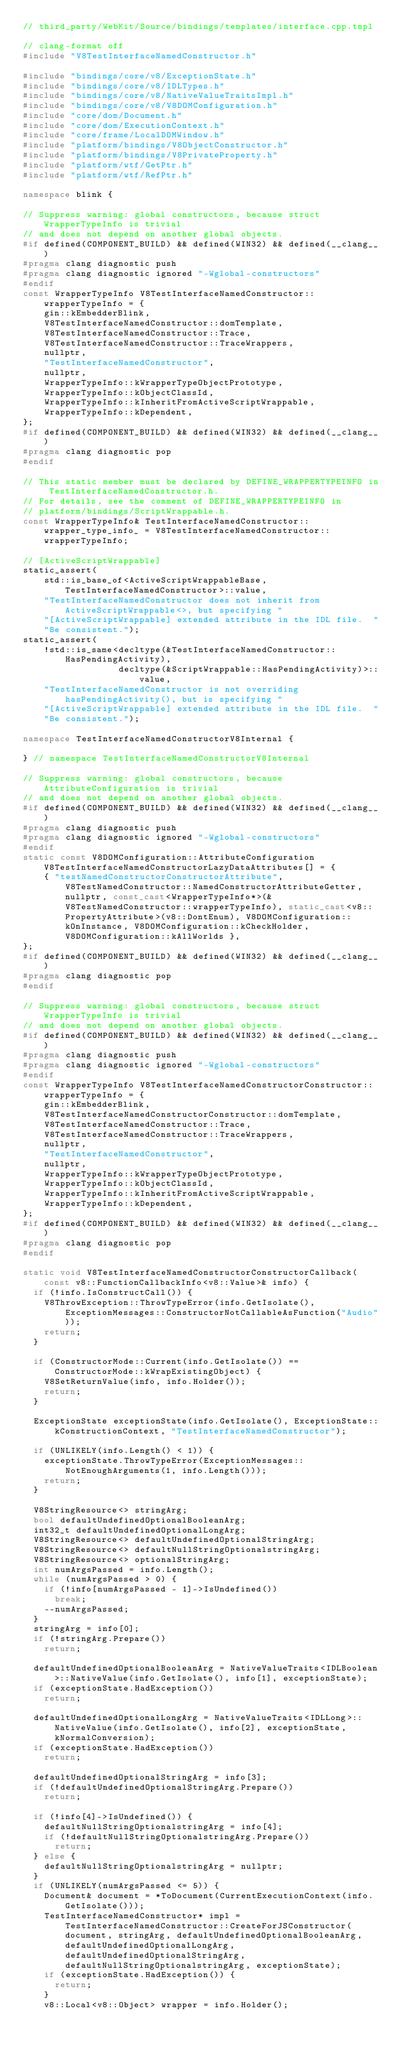Convert code to text. <code><loc_0><loc_0><loc_500><loc_500><_C++_>// third_party/WebKit/Source/bindings/templates/interface.cpp.tmpl

// clang-format off
#include "V8TestInterfaceNamedConstructor.h"

#include "bindings/core/v8/ExceptionState.h"
#include "bindings/core/v8/IDLTypes.h"
#include "bindings/core/v8/NativeValueTraitsImpl.h"
#include "bindings/core/v8/V8DOMConfiguration.h"
#include "core/dom/Document.h"
#include "core/dom/ExecutionContext.h"
#include "core/frame/LocalDOMWindow.h"
#include "platform/bindings/V8ObjectConstructor.h"
#include "platform/bindings/V8PrivateProperty.h"
#include "platform/wtf/GetPtr.h"
#include "platform/wtf/RefPtr.h"

namespace blink {

// Suppress warning: global constructors, because struct WrapperTypeInfo is trivial
// and does not depend on another global objects.
#if defined(COMPONENT_BUILD) && defined(WIN32) && defined(__clang__)
#pragma clang diagnostic push
#pragma clang diagnostic ignored "-Wglobal-constructors"
#endif
const WrapperTypeInfo V8TestInterfaceNamedConstructor::wrapperTypeInfo = {
    gin::kEmbedderBlink,
    V8TestInterfaceNamedConstructor::domTemplate,
    V8TestInterfaceNamedConstructor::Trace,
    V8TestInterfaceNamedConstructor::TraceWrappers,
    nullptr,
    "TestInterfaceNamedConstructor",
    nullptr,
    WrapperTypeInfo::kWrapperTypeObjectPrototype,
    WrapperTypeInfo::kObjectClassId,
    WrapperTypeInfo::kInheritFromActiveScriptWrappable,
    WrapperTypeInfo::kDependent,
};
#if defined(COMPONENT_BUILD) && defined(WIN32) && defined(__clang__)
#pragma clang diagnostic pop
#endif

// This static member must be declared by DEFINE_WRAPPERTYPEINFO in TestInterfaceNamedConstructor.h.
// For details, see the comment of DEFINE_WRAPPERTYPEINFO in
// platform/bindings/ScriptWrappable.h.
const WrapperTypeInfo& TestInterfaceNamedConstructor::wrapper_type_info_ = V8TestInterfaceNamedConstructor::wrapperTypeInfo;

// [ActiveScriptWrappable]
static_assert(
    std::is_base_of<ActiveScriptWrappableBase, TestInterfaceNamedConstructor>::value,
    "TestInterfaceNamedConstructor does not inherit from ActiveScriptWrappable<>, but specifying "
    "[ActiveScriptWrappable] extended attribute in the IDL file.  "
    "Be consistent.");
static_assert(
    !std::is_same<decltype(&TestInterfaceNamedConstructor::HasPendingActivity),
                  decltype(&ScriptWrappable::HasPendingActivity)>::value,
    "TestInterfaceNamedConstructor is not overriding hasPendingActivity(), but is specifying "
    "[ActiveScriptWrappable] extended attribute in the IDL file.  "
    "Be consistent.");

namespace TestInterfaceNamedConstructorV8Internal {

} // namespace TestInterfaceNamedConstructorV8Internal

// Suppress warning: global constructors, because AttributeConfiguration is trivial
// and does not depend on another global objects.
#if defined(COMPONENT_BUILD) && defined(WIN32) && defined(__clang__)
#pragma clang diagnostic push
#pragma clang diagnostic ignored "-Wglobal-constructors"
#endif
static const V8DOMConfiguration::AttributeConfiguration V8TestInterfaceNamedConstructorLazyDataAttributes[] = {
    { "testNamedConstructorConstructorAttribute", V8TestNamedConstructor::NamedConstructorAttributeGetter, nullptr, const_cast<WrapperTypeInfo*>(&V8TestNamedConstructor::wrapperTypeInfo), static_cast<v8::PropertyAttribute>(v8::DontEnum), V8DOMConfiguration::kOnInstance, V8DOMConfiguration::kCheckHolder, V8DOMConfiguration::kAllWorlds },
};
#if defined(COMPONENT_BUILD) && defined(WIN32) && defined(__clang__)
#pragma clang diagnostic pop
#endif

// Suppress warning: global constructors, because struct WrapperTypeInfo is trivial
// and does not depend on another global objects.
#if defined(COMPONENT_BUILD) && defined(WIN32) && defined(__clang__)
#pragma clang diagnostic push
#pragma clang diagnostic ignored "-Wglobal-constructors"
#endif
const WrapperTypeInfo V8TestInterfaceNamedConstructorConstructor::wrapperTypeInfo = {
    gin::kEmbedderBlink,
    V8TestInterfaceNamedConstructorConstructor::domTemplate,
    V8TestInterfaceNamedConstructor::Trace,
    V8TestInterfaceNamedConstructor::TraceWrappers,
    nullptr,
    "TestInterfaceNamedConstructor",
    nullptr,
    WrapperTypeInfo::kWrapperTypeObjectPrototype,
    WrapperTypeInfo::kObjectClassId,
    WrapperTypeInfo::kInheritFromActiveScriptWrappable,
    WrapperTypeInfo::kDependent,
};
#if defined(COMPONENT_BUILD) && defined(WIN32) && defined(__clang__)
#pragma clang diagnostic pop
#endif

static void V8TestInterfaceNamedConstructorConstructorCallback(const v8::FunctionCallbackInfo<v8::Value>& info) {
  if (!info.IsConstructCall()) {
    V8ThrowException::ThrowTypeError(info.GetIsolate(), ExceptionMessages::ConstructorNotCallableAsFunction("Audio"));
    return;
  }

  if (ConstructorMode::Current(info.GetIsolate()) == ConstructorMode::kWrapExistingObject) {
    V8SetReturnValue(info, info.Holder());
    return;
  }

  ExceptionState exceptionState(info.GetIsolate(), ExceptionState::kConstructionContext, "TestInterfaceNamedConstructor");

  if (UNLIKELY(info.Length() < 1)) {
    exceptionState.ThrowTypeError(ExceptionMessages::NotEnoughArguments(1, info.Length()));
    return;
  }

  V8StringResource<> stringArg;
  bool defaultUndefinedOptionalBooleanArg;
  int32_t defaultUndefinedOptionalLongArg;
  V8StringResource<> defaultUndefinedOptionalStringArg;
  V8StringResource<> defaultNullStringOptionalstringArg;
  V8StringResource<> optionalStringArg;
  int numArgsPassed = info.Length();
  while (numArgsPassed > 0) {
    if (!info[numArgsPassed - 1]->IsUndefined())
      break;
    --numArgsPassed;
  }
  stringArg = info[0];
  if (!stringArg.Prepare())
    return;

  defaultUndefinedOptionalBooleanArg = NativeValueTraits<IDLBoolean>::NativeValue(info.GetIsolate(), info[1], exceptionState);
  if (exceptionState.HadException())
    return;

  defaultUndefinedOptionalLongArg = NativeValueTraits<IDLLong>::NativeValue(info.GetIsolate(), info[2], exceptionState, kNormalConversion);
  if (exceptionState.HadException())
    return;

  defaultUndefinedOptionalStringArg = info[3];
  if (!defaultUndefinedOptionalStringArg.Prepare())
    return;

  if (!info[4]->IsUndefined()) {
    defaultNullStringOptionalstringArg = info[4];
    if (!defaultNullStringOptionalstringArg.Prepare())
      return;
  } else {
    defaultNullStringOptionalstringArg = nullptr;
  }
  if (UNLIKELY(numArgsPassed <= 5)) {
    Document& document = *ToDocument(CurrentExecutionContext(info.GetIsolate()));
    TestInterfaceNamedConstructor* impl = TestInterfaceNamedConstructor::CreateForJSConstructor(document, stringArg, defaultUndefinedOptionalBooleanArg, defaultUndefinedOptionalLongArg, defaultUndefinedOptionalStringArg, defaultNullStringOptionalstringArg, exceptionState);
    if (exceptionState.HadException()) {
      return;
    }
    v8::Local<v8::Object> wrapper = info.Holder();</code> 